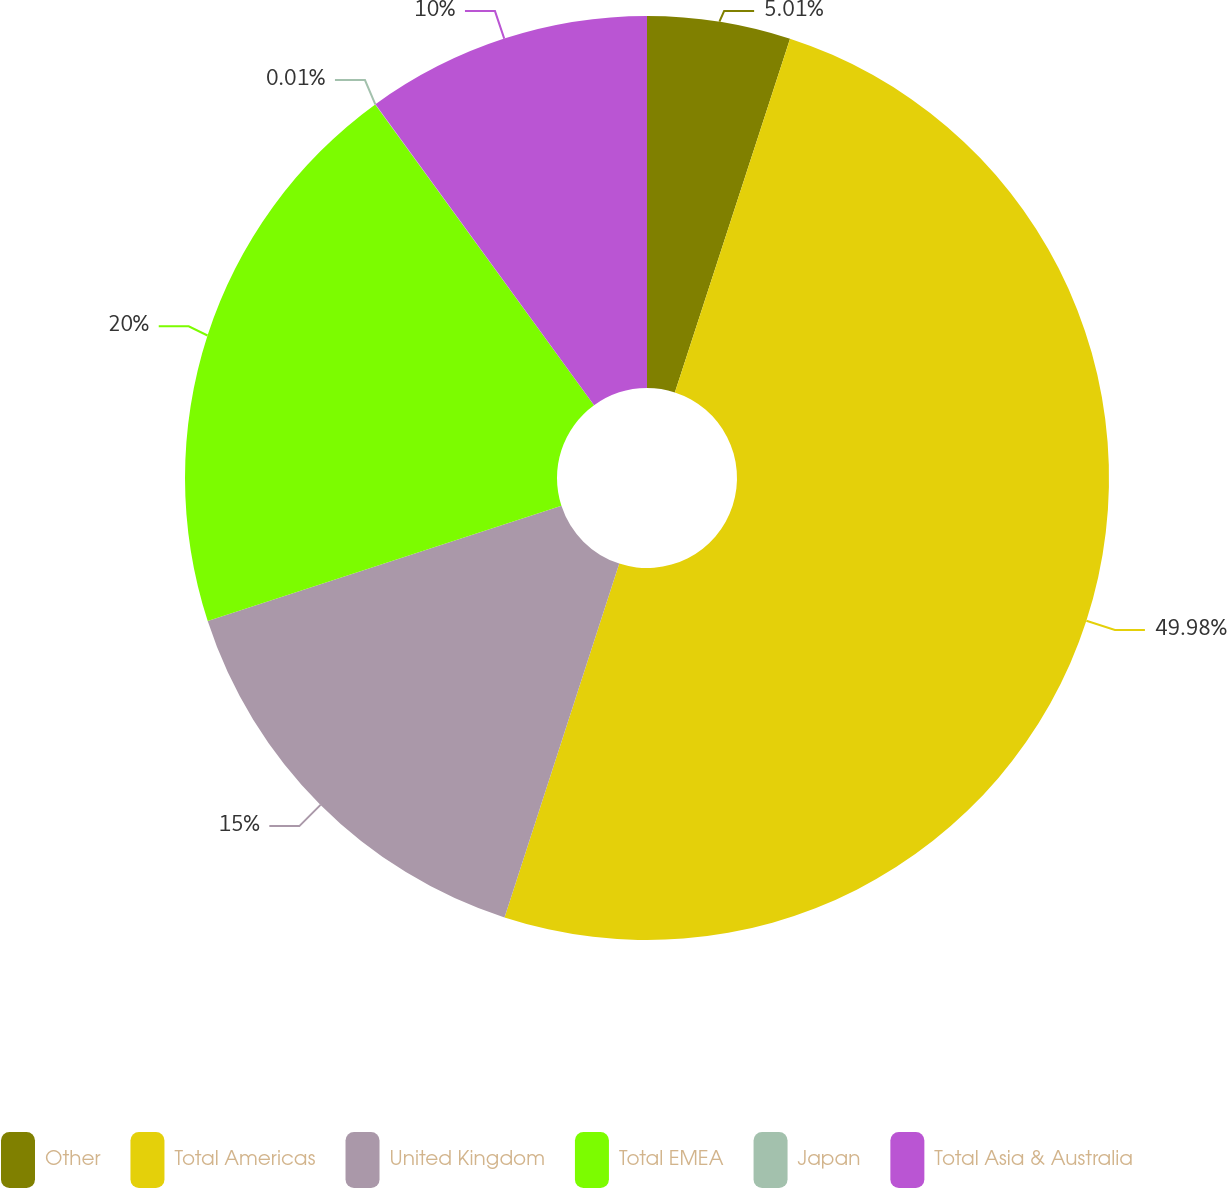Convert chart. <chart><loc_0><loc_0><loc_500><loc_500><pie_chart><fcel>Other<fcel>Total Americas<fcel>United Kingdom<fcel>Total EMEA<fcel>Japan<fcel>Total Asia & Australia<nl><fcel>5.01%<fcel>49.98%<fcel>15.0%<fcel>20.0%<fcel>0.01%<fcel>10.0%<nl></chart> 